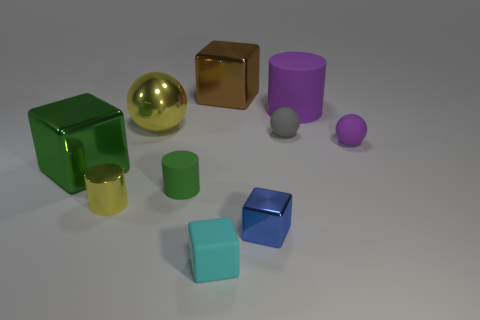Subtract all small shiny blocks. How many blocks are left? 3 Subtract all green cylinders. How many cylinders are left? 2 Subtract 1 cylinders. How many cylinders are left? 2 Subtract all cylinders. How many objects are left? 7 Subtract 1 green blocks. How many objects are left? 9 Subtract all green cubes. Subtract all brown spheres. How many cubes are left? 3 Subtract all large blue shiny things. Subtract all small gray matte objects. How many objects are left? 9 Add 5 large matte objects. How many large matte objects are left? 6 Add 1 yellow metallic cubes. How many yellow metallic cubes exist? 1 